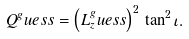<formula> <loc_0><loc_0><loc_500><loc_500>Q ^ { g } u e s s = \left ( L _ { z } ^ { g } u e s s \right ) ^ { 2 } \, \tan ^ { 2 } \iota .</formula> 